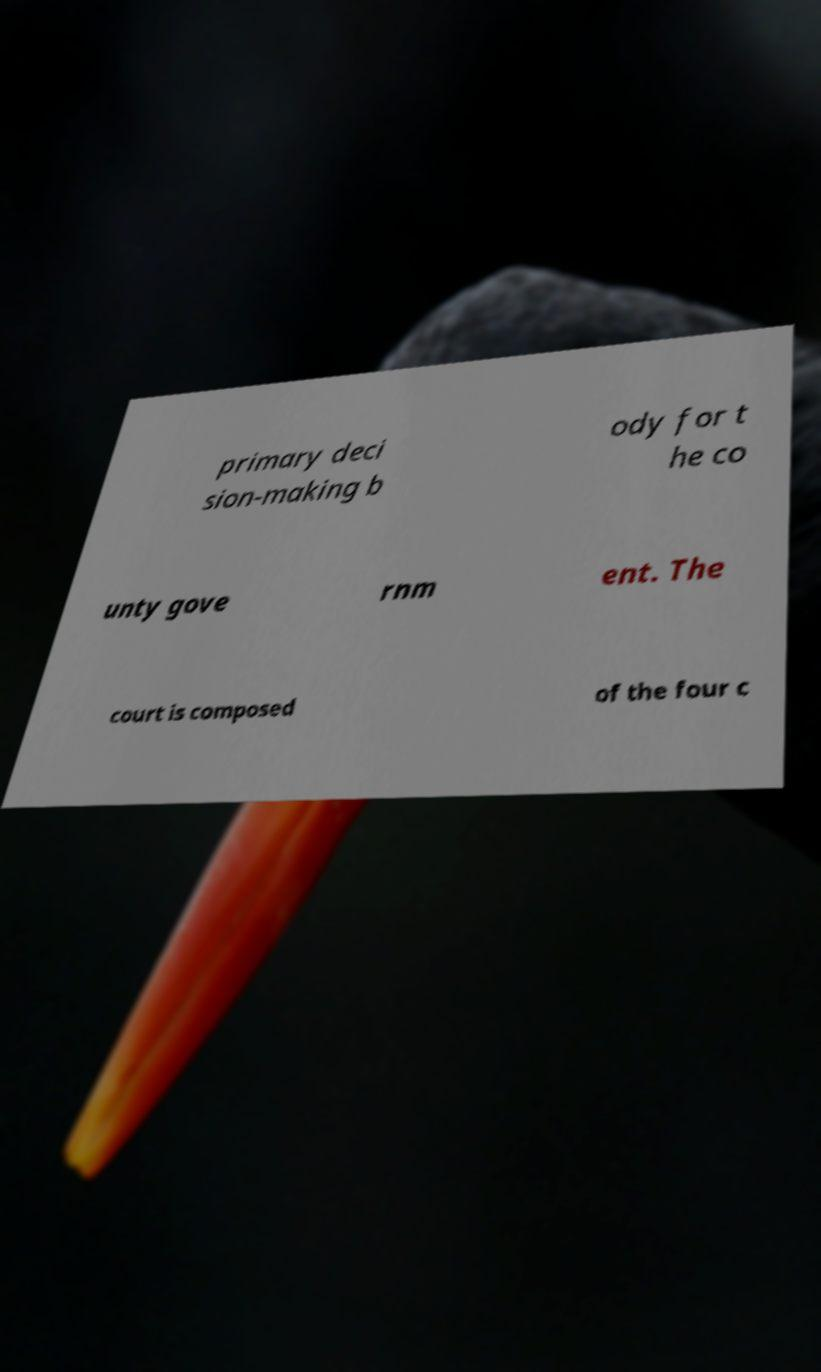For documentation purposes, I need the text within this image transcribed. Could you provide that? primary deci sion-making b ody for t he co unty gove rnm ent. The court is composed of the four c 